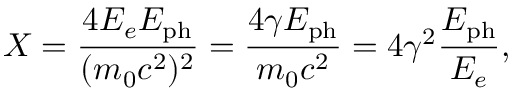<formula> <loc_0><loc_0><loc_500><loc_500>X = \frac { 4 E _ { e } E _ { p h } } { ( m _ { 0 } c ^ { 2 } ) ^ { 2 } } = \frac { 4 \gamma E _ { p h } } { m _ { 0 } c ^ { 2 } } = 4 \gamma ^ { 2 } \frac { E _ { p h } } { E _ { e } } ,</formula> 